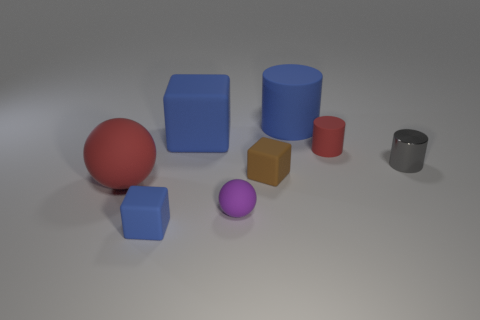Do the large rubber cube and the large cylinder have the same color?
Offer a very short reply. Yes. There is a rubber object that is in front of the big blue cube and behind the brown thing; what size is it?
Ensure brevity in your answer.  Small. What number of other things are the same color as the tiny matte cylinder?
Keep it short and to the point. 1. Are the red thing that is on the left side of the small brown object and the tiny blue object made of the same material?
Provide a short and direct response. Yes. Is there anything else that is the same size as the red sphere?
Give a very brief answer. Yes. Are there fewer blue objects that are on the right side of the small brown thing than big red rubber spheres that are to the left of the big red ball?
Your answer should be compact. No. Are there any other things that are the same shape as the small blue object?
Make the answer very short. Yes. There is a small cylinder that is the same color as the large sphere; what material is it?
Your response must be concise. Rubber. What number of small matte cylinders are behind the blue cube that is in front of the red thing left of the small red cylinder?
Offer a terse response. 1. What number of tiny metallic cylinders are to the left of the tiny matte sphere?
Your response must be concise. 0. 